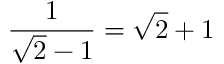<formula> <loc_0><loc_0><loc_500><loc_500>\, \ { \frac { 1 } { { \sqrt { 2 } } - 1 } } = { \sqrt { 2 } } + 1</formula> 